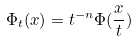<formula> <loc_0><loc_0><loc_500><loc_500>\Phi _ { t } ( x ) = t ^ { - n } \Phi ( \frac { x } { t } )</formula> 